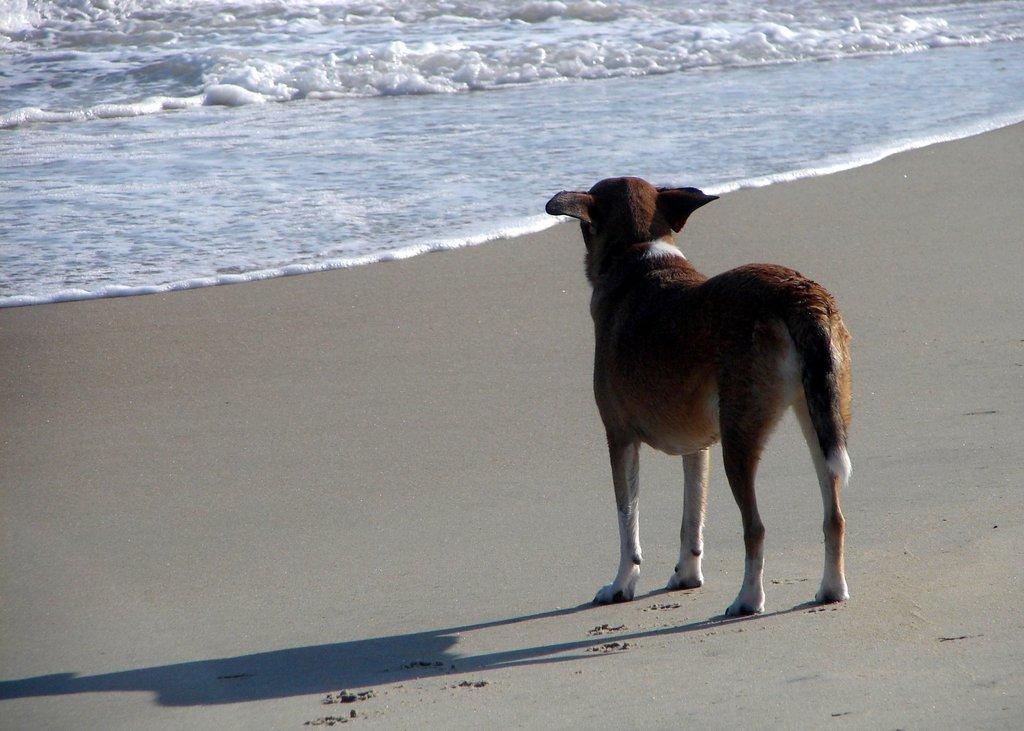What is the main subject in the foreground of the image? There is a dog in the foreground of the image. What is the dog standing on? The dog is standing on the grass. What can be seen in the background of the image? There is water visible at the top of the image. What type of wood is the dog chewing on in the image? There is no wood present in the image; the dog is standing on the grass. 